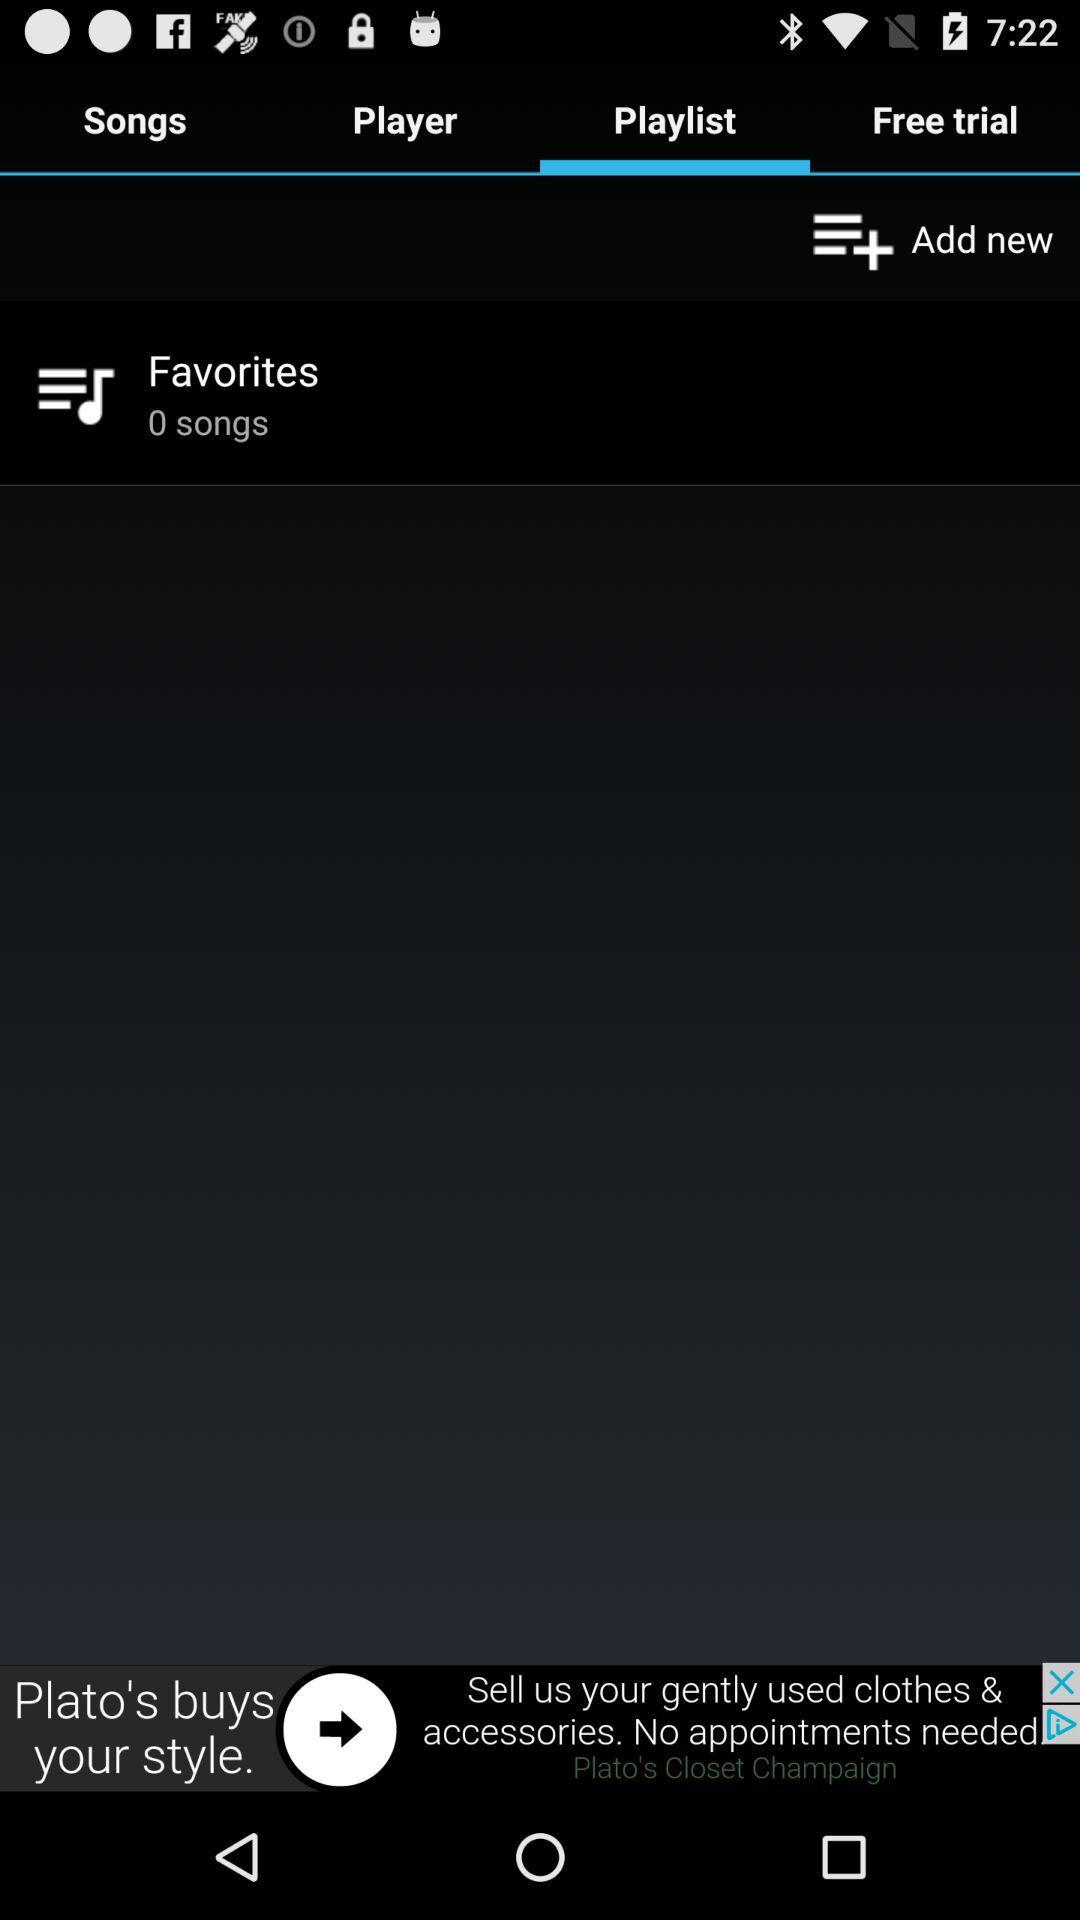Which tab is selected? The selected tab is "Playlist". 